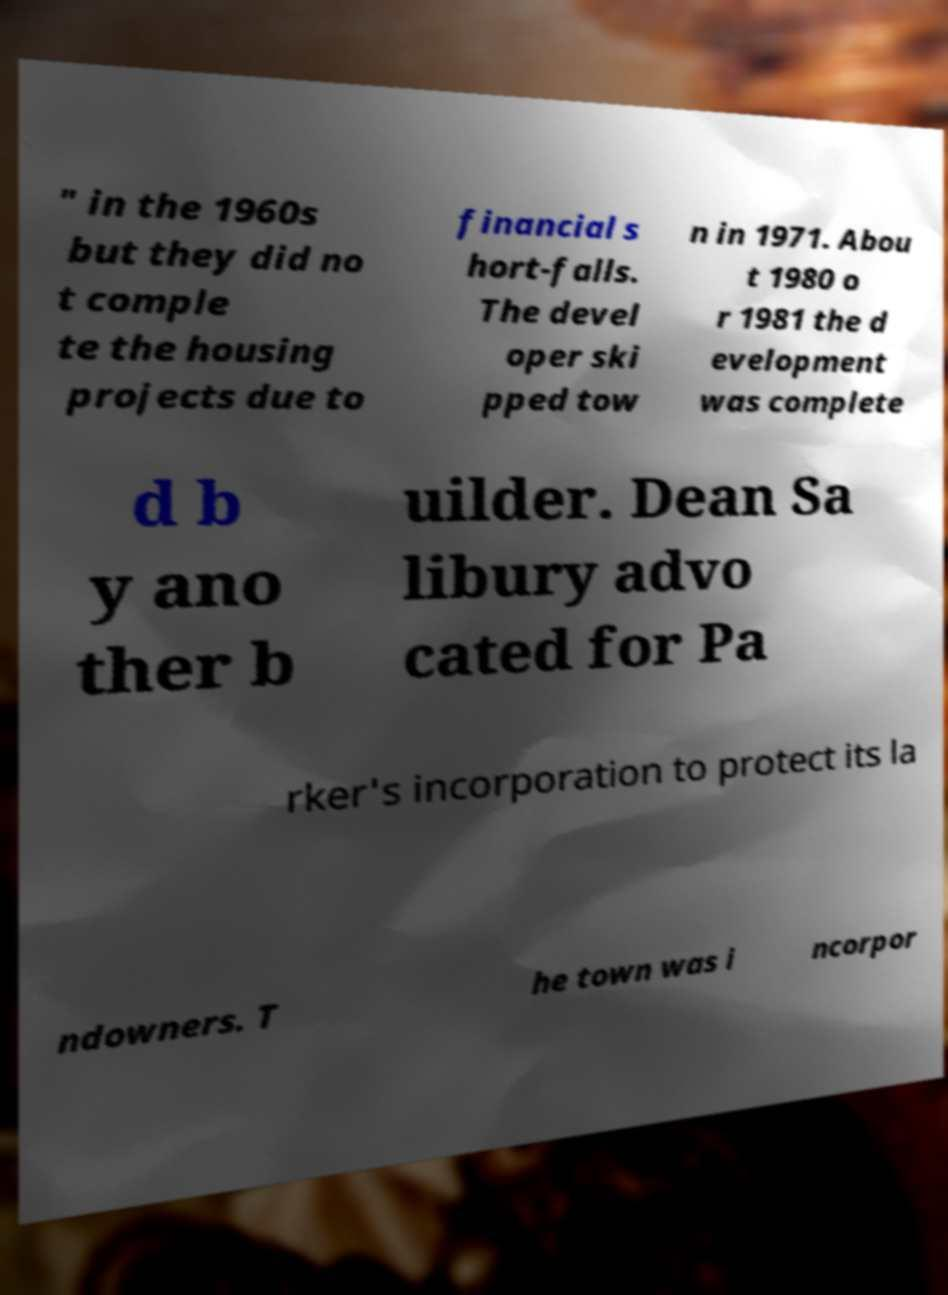Please identify and transcribe the text found in this image. " in the 1960s but they did no t comple te the housing projects due to financial s hort-falls. The devel oper ski pped tow n in 1971. Abou t 1980 o r 1981 the d evelopment was complete d b y ano ther b uilder. Dean Sa libury advo cated for Pa rker's incorporation to protect its la ndowners. T he town was i ncorpor 